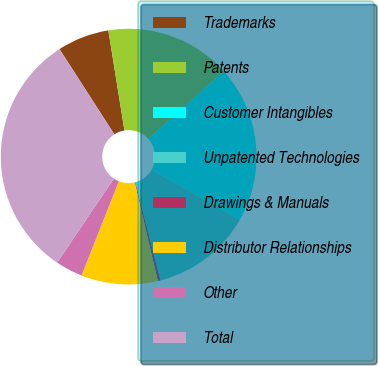Convert chart to OTSL. <chart><loc_0><loc_0><loc_500><loc_500><pie_chart><fcel>Trademarks<fcel>Patents<fcel>Customer Intangibles<fcel>Unpatented Technologies<fcel>Drawings & Manuals<fcel>Distributor Relationships<fcel>Other<fcel>Total<nl><fcel>6.56%<fcel>15.89%<fcel>19.86%<fcel>12.78%<fcel>0.34%<fcel>9.67%<fcel>3.45%<fcel>31.45%<nl></chart> 